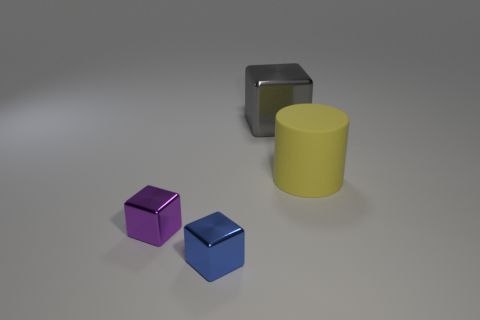Do the large matte thing and the object behind the yellow cylinder have the same color? The large object, which appears to have a matte finish, and the object situated behind the yellow cylinder do not share the same color. The large object has a distinct silver-gray hue, whereas the item in question behind the yellow cylinder appears to be a deeper shade, possibly a dark gray or black. 